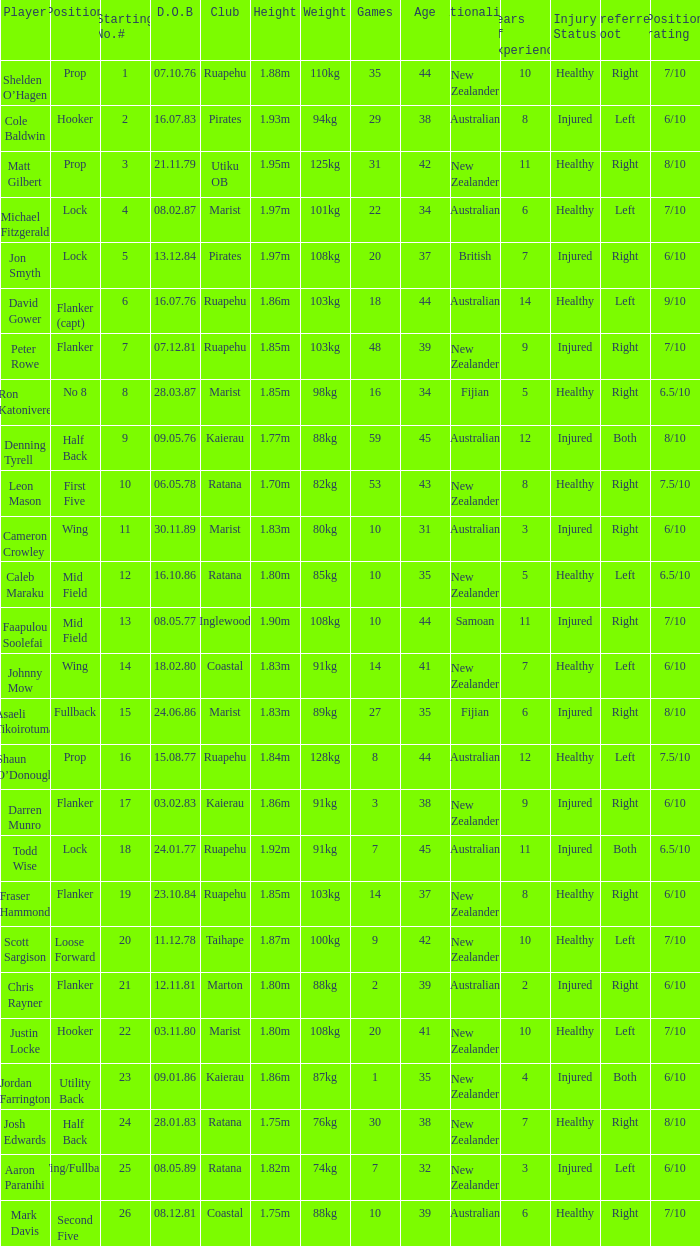Could you parse the entire table as a dict? {'header': ['Player', 'Position', 'Starting No.#', 'D.O.B', 'Club', 'Height', 'Weight', 'Games', 'Age', 'Nationality', 'Years of experience', 'Injury Status', 'Preferred foot', 'Position rating'], 'rows': [['Shelden O’Hagen', 'Prop', '1', '07.10.76', 'Ruapehu', '1.88m', '110kg', '35', '44', 'New Zealander', '10', 'Healthy', 'Right', '7/10'], ['Cole Baldwin', 'Hooker', '2', '16.07.83', 'Pirates', '1.93m', '94kg', '29', '38', 'Australian', '8', 'Injured', 'Left', '6/10'], ['Matt Gilbert', 'Prop', '3', '21.11.79', 'Utiku OB', '1.95m', '125kg', '31', '42', 'New Zealander', '11', 'Healthy', 'Right', '8/10'], ['Michael Fitzgerald', 'Lock', '4', '08.02.87', 'Marist', '1.97m', '101kg', '22', '34', 'Australian', '6', 'Healthy', 'Left', '7/10'], ['Jon Smyth', 'Lock', '5', '13.12.84', 'Pirates', '1.97m', '108kg', '20', '37', 'British', '7', 'Injured', 'Right', '6/10'], ['David Gower', 'Flanker (capt)', '6', '16.07.76', 'Ruapehu', '1.86m', '103kg', '18', '44', 'Australian', '14', 'Healthy', 'Left', '9/10'], ['Peter Rowe', 'Flanker', '7', '07.12.81', 'Ruapehu', '1.85m', '103kg', '48', '39', 'New Zealander', '9', 'Injured', 'Right', '7/10'], ['Ron Katonivere', 'No 8', '8', '28.03.87', 'Marist', '1.85m', '98kg', '16', '34', 'Fijian', '5', 'Healthy', 'Right', '6.5/10'], ['Denning Tyrell', 'Half Back', '9', '09.05.76', 'Kaierau', '1.77m', '88kg', '59', '45', 'Australian', '12', 'Injured', 'Both', '8/10'], ['Leon Mason', 'First Five', '10', '06.05.78', 'Ratana', '1.70m', '82kg', '53', '43', 'New Zealander', '8', 'Healthy', 'Right', '7.5/10'], ['Cameron Crowley', 'Wing', '11', '30.11.89', 'Marist', '1.83m', '80kg', '10', '31', 'Australian', '3', 'Injured', 'Right', '6/10'], ['Caleb Maraku', 'Mid Field', '12', '16.10.86', 'Ratana', '1.80m', '85kg', '10', '35', 'New Zealander', '5', 'Healthy', 'Left', '6.5/10'], ['Faapulou Soolefai', 'Mid Field', '13', '08.05.77', 'Inglewood', '1.90m', '108kg', '10', '44', 'Samoan', '11', 'Injured', 'Right', '7/10'], ['Johnny Mow', 'Wing', '14', '18.02.80', 'Coastal', '1.83m', '91kg', '14', '41', 'New Zealander', '7', 'Healthy', 'Left', '6/10'], ['Asaeli Tikoirotuma', 'Fullback', '15', '24.06.86', 'Marist', '1.83m', '89kg', '27', '35', 'Fijian', '6', 'Injured', 'Right', '8/10'], ['Shaun O’Donough', 'Prop', '16', '15.08.77', 'Ruapehu', '1.84m', '128kg', '8', '44', 'Australian', '12', 'Healthy', 'Left', '7.5/10'], ['Darren Munro', 'Flanker', '17', '03.02.83', 'Kaierau', '1.86m', '91kg', '3', '38', 'New Zealander', '9', 'Injured', 'Right', '6/10'], ['Todd Wise', 'Lock', '18', '24.01.77', 'Ruapehu', '1.92m', '91kg', '7', '45', 'Australian', '11', 'Injured', 'Both', '6.5/10'], ['Fraser Hammond', 'Flanker', '19', '23.10.84', 'Ruapehu', '1.85m', '103kg', '14', '37', 'New Zealander', '8', 'Healthy', 'Right', '6/10'], ['Scott Sargison', 'Loose Forward', '20', '11.12.78', 'Taihape', '1.87m', '100kg', '9', '42', 'New Zealander', '10', 'Healthy', 'Left', '7/10'], ['Chris Rayner', 'Flanker', '21', '12.11.81', 'Marton', '1.80m', '88kg', '2', '39', 'Australian', '2', 'Injured', 'Right', '6/10'], ['Justin Locke', 'Hooker', '22', '03.11.80', 'Marist', '1.80m', '108kg', '20', '41', 'New Zealander', '10', 'Healthy', 'Left', '7/10'], ['Jordan Farrington', 'Utility Back', '23', '09.01.86', 'Kaierau', '1.86m', '87kg', '1', '35', 'New Zealander', '4', 'Injured', 'Both', '6/10'], ['Josh Edwards', 'Half Back', '24', '28.01.83', 'Ratana', '1.75m', '76kg', '30', '38', 'New Zealander', '7', 'Healthy', 'Right', '8/10'], ['Aaron Paranihi', 'Wing/Fullback', '25', '08.05.89', 'Ratana', '1.82m', '74kg', '7', '32', 'New Zealander', '3', 'Injured', 'Left', '6/10'], ['Mark Davis', 'Second Five', '26', '08.12.81', 'Coastal', '1.75m', '88kg', '10', '39', 'Australian', '6', 'Healthy', 'Right', '7/10']]} Which player weighs 76kg? Josh Edwards. 